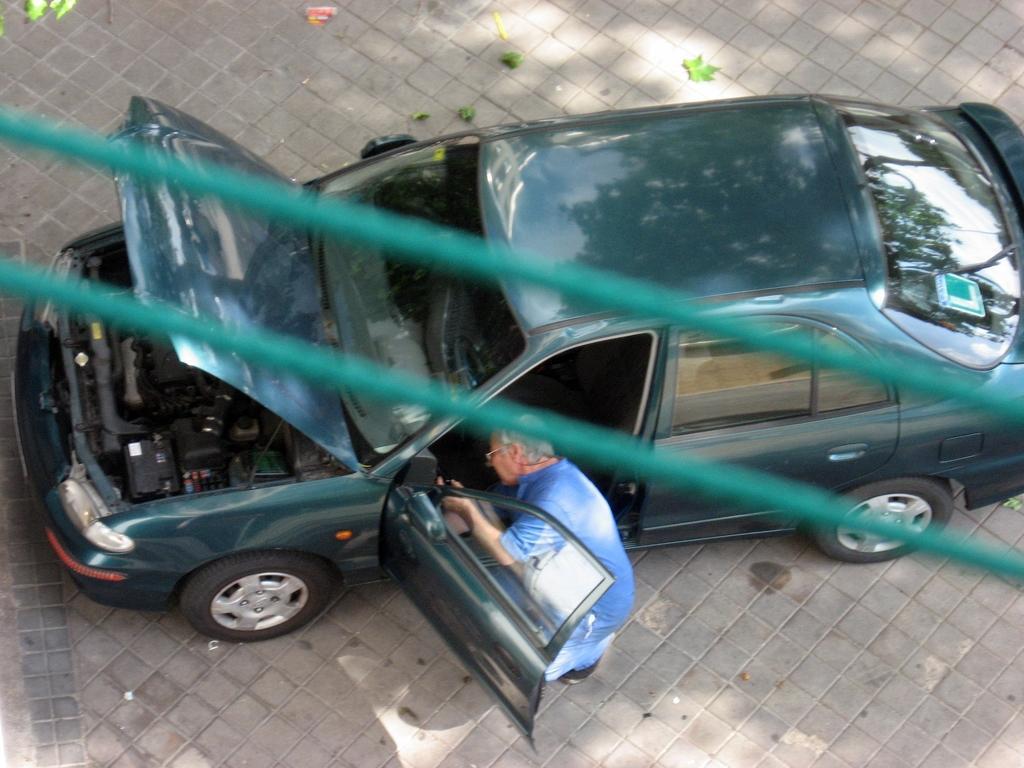How would you summarize this image in a sentence or two? In this image we can see a car parked on the ground, we can also see a person standing and holding an object in his hand. In the foreground we can see some cables. 